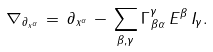Convert formula to latex. <formula><loc_0><loc_0><loc_500><loc_500>\nabla _ { \partial _ { x ^ { \alpha } } } \, = \, \partial _ { x ^ { \alpha } } \, - \, \sum _ { \beta , \gamma } \Gamma ^ { \gamma } _ { \, \beta \alpha } \, E ^ { \beta } \, I _ { \gamma } .</formula> 